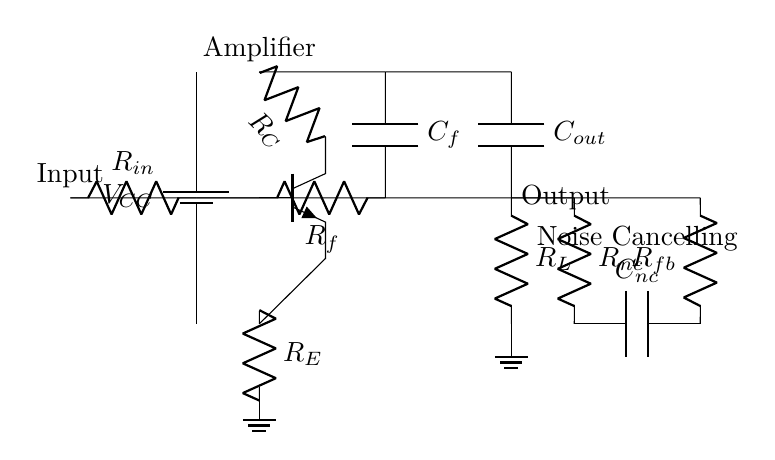What is the input resistor value in this circuit? The circuit diagram shows an input resistor labeled as R_in, but it doesn't specify its value, so the answer cannot be determined just from the diagram. However, it is a critical component for the input stage of the amplifier.
Answer: R_in What type of transistor is used in this circuit? The diagram indicates an npn transistor with the label Q, but does not provide specific details on its model or characteristics. This is commonly used for amplification in hybrid circuits.
Answer: npn What is the function of R_fb in this hybrid amplifier circuit? R_fb is described as part of the feedback network, which is essential for controlling the gain and stability of the amplifier. Feedback helps reduce distortion in the output signal by comparing it to the input signal.
Answer: Gain control How many capacitors are present in this circuit? The circuit diagram depicts three capacitors: C_f, C_out, and C_nc, each serving specific roles in the feedback and output stages which help in frequency response and noise cancellation.
Answer: Three What is the purpose of the noise cancelling feedback network? The noise cancelling feedback network, which consists of R_nc and C_nc, aims to reduce unwanted noise signals from the environment, thereby enhancing focus while using noise-cancelling headphones.
Answer: Noise reduction What happens to the output when R_L is changed? Changing the load resistor R_L impacts the output impedance and can affect the circuit's performance, specifically reducing current flow when increased resistance is added, which can influence the amplifier's ability to drive the load.
Answer: Affects output What is the overall function of this hybrid amplifier circuit? The hybrid amplifier circuit is designed specifically to amplify audio signals while simultaneously cancelling out background noise, providing a clearer listening experience—particularly useful for focusing during study sessions.
Answer: Audio amplification 